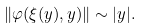<formula> <loc_0><loc_0><loc_500><loc_500>\| \varphi ( \xi ( y ) , y ) \| \sim | y | .</formula> 